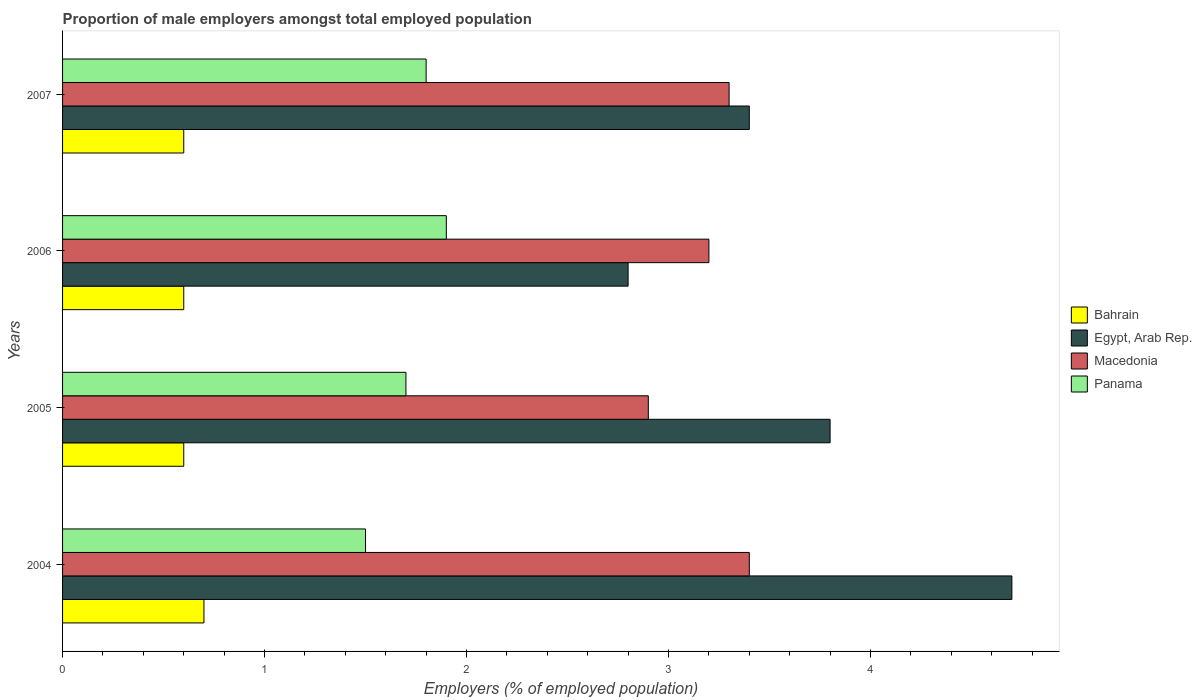Are the number of bars on each tick of the Y-axis equal?
Offer a terse response. Yes. What is the label of the 3rd group of bars from the top?
Keep it short and to the point. 2005. What is the proportion of male employers in Egypt, Arab Rep. in 2006?
Offer a very short reply. 2.8. Across all years, what is the maximum proportion of male employers in Panama?
Provide a short and direct response. 1.9. Across all years, what is the minimum proportion of male employers in Panama?
Give a very brief answer. 1.5. In which year was the proportion of male employers in Bahrain maximum?
Your answer should be compact. 2004. In which year was the proportion of male employers in Egypt, Arab Rep. minimum?
Ensure brevity in your answer.  2006. What is the total proportion of male employers in Macedonia in the graph?
Ensure brevity in your answer.  12.8. What is the difference between the proportion of male employers in Egypt, Arab Rep. in 2006 and the proportion of male employers in Panama in 2007?
Your response must be concise. 1. What is the average proportion of male employers in Macedonia per year?
Offer a very short reply. 3.2. In the year 2004, what is the difference between the proportion of male employers in Macedonia and proportion of male employers in Egypt, Arab Rep.?
Keep it short and to the point. -1.3. What is the ratio of the proportion of male employers in Panama in 2004 to that in 2007?
Ensure brevity in your answer.  0.83. Is the difference between the proportion of male employers in Macedonia in 2005 and 2007 greater than the difference between the proportion of male employers in Egypt, Arab Rep. in 2005 and 2007?
Ensure brevity in your answer.  No. What is the difference between the highest and the second highest proportion of male employers in Panama?
Offer a very short reply. 0.1. What is the difference between the highest and the lowest proportion of male employers in Egypt, Arab Rep.?
Keep it short and to the point. 1.9. In how many years, is the proportion of male employers in Egypt, Arab Rep. greater than the average proportion of male employers in Egypt, Arab Rep. taken over all years?
Make the answer very short. 2. What does the 1st bar from the top in 2006 represents?
Offer a terse response. Panama. What does the 1st bar from the bottom in 2006 represents?
Provide a succinct answer. Bahrain. How many bars are there?
Give a very brief answer. 16. How many years are there in the graph?
Offer a terse response. 4. What is the difference between two consecutive major ticks on the X-axis?
Provide a succinct answer. 1. Does the graph contain any zero values?
Make the answer very short. No. How are the legend labels stacked?
Ensure brevity in your answer.  Vertical. What is the title of the graph?
Give a very brief answer. Proportion of male employers amongst total employed population. What is the label or title of the X-axis?
Your answer should be compact. Employers (% of employed population). What is the Employers (% of employed population) in Bahrain in 2004?
Give a very brief answer. 0.7. What is the Employers (% of employed population) in Egypt, Arab Rep. in 2004?
Provide a succinct answer. 4.7. What is the Employers (% of employed population) in Macedonia in 2004?
Your answer should be very brief. 3.4. What is the Employers (% of employed population) of Bahrain in 2005?
Make the answer very short. 0.6. What is the Employers (% of employed population) of Egypt, Arab Rep. in 2005?
Give a very brief answer. 3.8. What is the Employers (% of employed population) in Macedonia in 2005?
Your answer should be compact. 2.9. What is the Employers (% of employed population) in Panama in 2005?
Your response must be concise. 1.7. What is the Employers (% of employed population) of Bahrain in 2006?
Your answer should be very brief. 0.6. What is the Employers (% of employed population) of Egypt, Arab Rep. in 2006?
Offer a terse response. 2.8. What is the Employers (% of employed population) in Macedonia in 2006?
Your answer should be very brief. 3.2. What is the Employers (% of employed population) of Panama in 2006?
Your answer should be very brief. 1.9. What is the Employers (% of employed population) in Bahrain in 2007?
Your answer should be compact. 0.6. What is the Employers (% of employed population) of Egypt, Arab Rep. in 2007?
Keep it short and to the point. 3.4. What is the Employers (% of employed population) of Macedonia in 2007?
Make the answer very short. 3.3. What is the Employers (% of employed population) of Panama in 2007?
Ensure brevity in your answer.  1.8. Across all years, what is the maximum Employers (% of employed population) of Bahrain?
Your answer should be compact. 0.7. Across all years, what is the maximum Employers (% of employed population) of Egypt, Arab Rep.?
Provide a short and direct response. 4.7. Across all years, what is the maximum Employers (% of employed population) in Macedonia?
Offer a terse response. 3.4. Across all years, what is the maximum Employers (% of employed population) of Panama?
Ensure brevity in your answer.  1.9. Across all years, what is the minimum Employers (% of employed population) in Bahrain?
Provide a short and direct response. 0.6. Across all years, what is the minimum Employers (% of employed population) of Egypt, Arab Rep.?
Keep it short and to the point. 2.8. Across all years, what is the minimum Employers (% of employed population) in Macedonia?
Give a very brief answer. 2.9. What is the total Employers (% of employed population) of Macedonia in the graph?
Give a very brief answer. 12.8. What is the total Employers (% of employed population) in Panama in the graph?
Provide a short and direct response. 6.9. What is the difference between the Employers (% of employed population) of Macedonia in 2004 and that in 2005?
Provide a short and direct response. 0.5. What is the difference between the Employers (% of employed population) in Panama in 2004 and that in 2005?
Your answer should be compact. -0.2. What is the difference between the Employers (% of employed population) of Macedonia in 2004 and that in 2007?
Ensure brevity in your answer.  0.1. What is the difference between the Employers (% of employed population) in Panama in 2005 and that in 2006?
Your answer should be compact. -0.2. What is the difference between the Employers (% of employed population) in Bahrain in 2005 and that in 2007?
Your answer should be very brief. 0. What is the difference between the Employers (% of employed population) of Macedonia in 2005 and that in 2007?
Give a very brief answer. -0.4. What is the difference between the Employers (% of employed population) of Egypt, Arab Rep. in 2006 and that in 2007?
Keep it short and to the point. -0.6. What is the difference between the Employers (% of employed population) of Macedonia in 2006 and that in 2007?
Offer a very short reply. -0.1. What is the difference between the Employers (% of employed population) in Bahrain in 2004 and the Employers (% of employed population) in Macedonia in 2005?
Offer a very short reply. -2.2. What is the difference between the Employers (% of employed population) in Bahrain in 2004 and the Employers (% of employed population) in Egypt, Arab Rep. in 2006?
Give a very brief answer. -2.1. What is the difference between the Employers (% of employed population) in Bahrain in 2004 and the Employers (% of employed population) in Panama in 2006?
Offer a very short reply. -1.2. What is the difference between the Employers (% of employed population) of Egypt, Arab Rep. in 2004 and the Employers (% of employed population) of Panama in 2006?
Offer a very short reply. 2.8. What is the difference between the Employers (% of employed population) of Macedonia in 2004 and the Employers (% of employed population) of Panama in 2006?
Keep it short and to the point. 1.5. What is the difference between the Employers (% of employed population) in Bahrain in 2004 and the Employers (% of employed population) in Egypt, Arab Rep. in 2007?
Your response must be concise. -2.7. What is the difference between the Employers (% of employed population) of Bahrain in 2004 and the Employers (% of employed population) of Macedonia in 2007?
Offer a terse response. -2.6. What is the difference between the Employers (% of employed population) of Bahrain in 2004 and the Employers (% of employed population) of Panama in 2007?
Your answer should be very brief. -1.1. What is the difference between the Employers (% of employed population) of Egypt, Arab Rep. in 2004 and the Employers (% of employed population) of Macedonia in 2007?
Provide a succinct answer. 1.4. What is the difference between the Employers (% of employed population) of Macedonia in 2004 and the Employers (% of employed population) of Panama in 2007?
Make the answer very short. 1.6. What is the difference between the Employers (% of employed population) of Bahrain in 2005 and the Employers (% of employed population) of Panama in 2006?
Provide a succinct answer. -1.3. What is the difference between the Employers (% of employed population) in Egypt, Arab Rep. in 2005 and the Employers (% of employed population) in Macedonia in 2006?
Your answer should be very brief. 0.6. What is the difference between the Employers (% of employed population) in Egypt, Arab Rep. in 2005 and the Employers (% of employed population) in Panama in 2006?
Make the answer very short. 1.9. What is the difference between the Employers (% of employed population) of Macedonia in 2005 and the Employers (% of employed population) of Panama in 2006?
Your answer should be compact. 1. What is the difference between the Employers (% of employed population) in Bahrain in 2005 and the Employers (% of employed population) in Macedonia in 2007?
Your answer should be compact. -2.7. What is the difference between the Employers (% of employed population) of Egypt, Arab Rep. in 2005 and the Employers (% of employed population) of Macedonia in 2007?
Give a very brief answer. 0.5. What is the difference between the Employers (% of employed population) of Macedonia in 2005 and the Employers (% of employed population) of Panama in 2007?
Provide a succinct answer. 1.1. What is the difference between the Employers (% of employed population) of Bahrain in 2006 and the Employers (% of employed population) of Egypt, Arab Rep. in 2007?
Offer a terse response. -2.8. What is the difference between the Employers (% of employed population) of Bahrain in 2006 and the Employers (% of employed population) of Panama in 2007?
Keep it short and to the point. -1.2. What is the average Employers (% of employed population) of Bahrain per year?
Offer a terse response. 0.62. What is the average Employers (% of employed population) of Egypt, Arab Rep. per year?
Your answer should be very brief. 3.67. What is the average Employers (% of employed population) of Panama per year?
Keep it short and to the point. 1.73. In the year 2004, what is the difference between the Employers (% of employed population) of Bahrain and Employers (% of employed population) of Egypt, Arab Rep.?
Your answer should be very brief. -4. In the year 2004, what is the difference between the Employers (% of employed population) in Bahrain and Employers (% of employed population) in Macedonia?
Keep it short and to the point. -2.7. In the year 2004, what is the difference between the Employers (% of employed population) of Egypt, Arab Rep. and Employers (% of employed population) of Macedonia?
Provide a succinct answer. 1.3. In the year 2004, what is the difference between the Employers (% of employed population) in Egypt, Arab Rep. and Employers (% of employed population) in Panama?
Your answer should be compact. 3.2. In the year 2004, what is the difference between the Employers (% of employed population) of Macedonia and Employers (% of employed population) of Panama?
Give a very brief answer. 1.9. In the year 2005, what is the difference between the Employers (% of employed population) of Egypt, Arab Rep. and Employers (% of employed population) of Macedonia?
Offer a terse response. 0.9. In the year 2005, what is the difference between the Employers (% of employed population) of Egypt, Arab Rep. and Employers (% of employed population) of Panama?
Ensure brevity in your answer.  2.1. In the year 2005, what is the difference between the Employers (% of employed population) of Macedonia and Employers (% of employed population) of Panama?
Ensure brevity in your answer.  1.2. In the year 2006, what is the difference between the Employers (% of employed population) of Bahrain and Employers (% of employed population) of Egypt, Arab Rep.?
Your answer should be very brief. -2.2. In the year 2006, what is the difference between the Employers (% of employed population) in Bahrain and Employers (% of employed population) in Panama?
Your answer should be very brief. -1.3. In the year 2006, what is the difference between the Employers (% of employed population) in Egypt, Arab Rep. and Employers (% of employed population) in Panama?
Ensure brevity in your answer.  0.9. In the year 2006, what is the difference between the Employers (% of employed population) of Macedonia and Employers (% of employed population) of Panama?
Ensure brevity in your answer.  1.3. In the year 2007, what is the difference between the Employers (% of employed population) of Bahrain and Employers (% of employed population) of Egypt, Arab Rep.?
Make the answer very short. -2.8. In the year 2007, what is the difference between the Employers (% of employed population) in Bahrain and Employers (% of employed population) in Macedonia?
Keep it short and to the point. -2.7. In the year 2007, what is the difference between the Employers (% of employed population) in Macedonia and Employers (% of employed population) in Panama?
Offer a terse response. 1.5. What is the ratio of the Employers (% of employed population) of Bahrain in 2004 to that in 2005?
Your answer should be compact. 1.17. What is the ratio of the Employers (% of employed population) of Egypt, Arab Rep. in 2004 to that in 2005?
Ensure brevity in your answer.  1.24. What is the ratio of the Employers (% of employed population) of Macedonia in 2004 to that in 2005?
Offer a terse response. 1.17. What is the ratio of the Employers (% of employed population) of Panama in 2004 to that in 2005?
Your answer should be very brief. 0.88. What is the ratio of the Employers (% of employed population) in Egypt, Arab Rep. in 2004 to that in 2006?
Make the answer very short. 1.68. What is the ratio of the Employers (% of employed population) in Panama in 2004 to that in 2006?
Your response must be concise. 0.79. What is the ratio of the Employers (% of employed population) in Egypt, Arab Rep. in 2004 to that in 2007?
Your answer should be very brief. 1.38. What is the ratio of the Employers (% of employed population) in Macedonia in 2004 to that in 2007?
Provide a succinct answer. 1.03. What is the ratio of the Employers (% of employed population) of Egypt, Arab Rep. in 2005 to that in 2006?
Provide a succinct answer. 1.36. What is the ratio of the Employers (% of employed population) of Macedonia in 2005 to that in 2006?
Offer a very short reply. 0.91. What is the ratio of the Employers (% of employed population) of Panama in 2005 to that in 2006?
Make the answer very short. 0.89. What is the ratio of the Employers (% of employed population) of Egypt, Arab Rep. in 2005 to that in 2007?
Give a very brief answer. 1.12. What is the ratio of the Employers (% of employed population) in Macedonia in 2005 to that in 2007?
Provide a short and direct response. 0.88. What is the ratio of the Employers (% of employed population) in Bahrain in 2006 to that in 2007?
Your response must be concise. 1. What is the ratio of the Employers (% of employed population) in Egypt, Arab Rep. in 2006 to that in 2007?
Provide a short and direct response. 0.82. What is the ratio of the Employers (% of employed population) in Macedonia in 2006 to that in 2007?
Offer a very short reply. 0.97. What is the ratio of the Employers (% of employed population) in Panama in 2006 to that in 2007?
Give a very brief answer. 1.06. What is the difference between the highest and the second highest Employers (% of employed population) in Bahrain?
Offer a terse response. 0.1. What is the difference between the highest and the second highest Employers (% of employed population) in Egypt, Arab Rep.?
Ensure brevity in your answer.  0.9. What is the difference between the highest and the second highest Employers (% of employed population) of Macedonia?
Provide a succinct answer. 0.1. What is the difference between the highest and the second highest Employers (% of employed population) in Panama?
Keep it short and to the point. 0.1. What is the difference between the highest and the lowest Employers (% of employed population) in Macedonia?
Give a very brief answer. 0.5. 